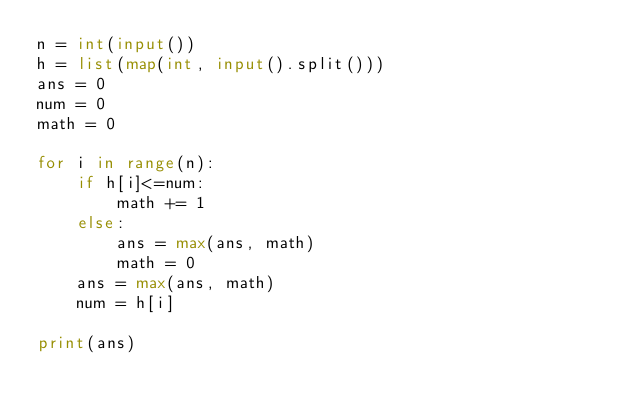<code> <loc_0><loc_0><loc_500><loc_500><_Python_>n = int(input())
h = list(map(int, input().split()))
ans = 0
num = 0
math = 0

for i in range(n):
    if h[i]<=num:
        math += 1
    else:
        ans = max(ans, math)
        math = 0
    ans = max(ans, math)
    num = h[i]

print(ans)</code> 